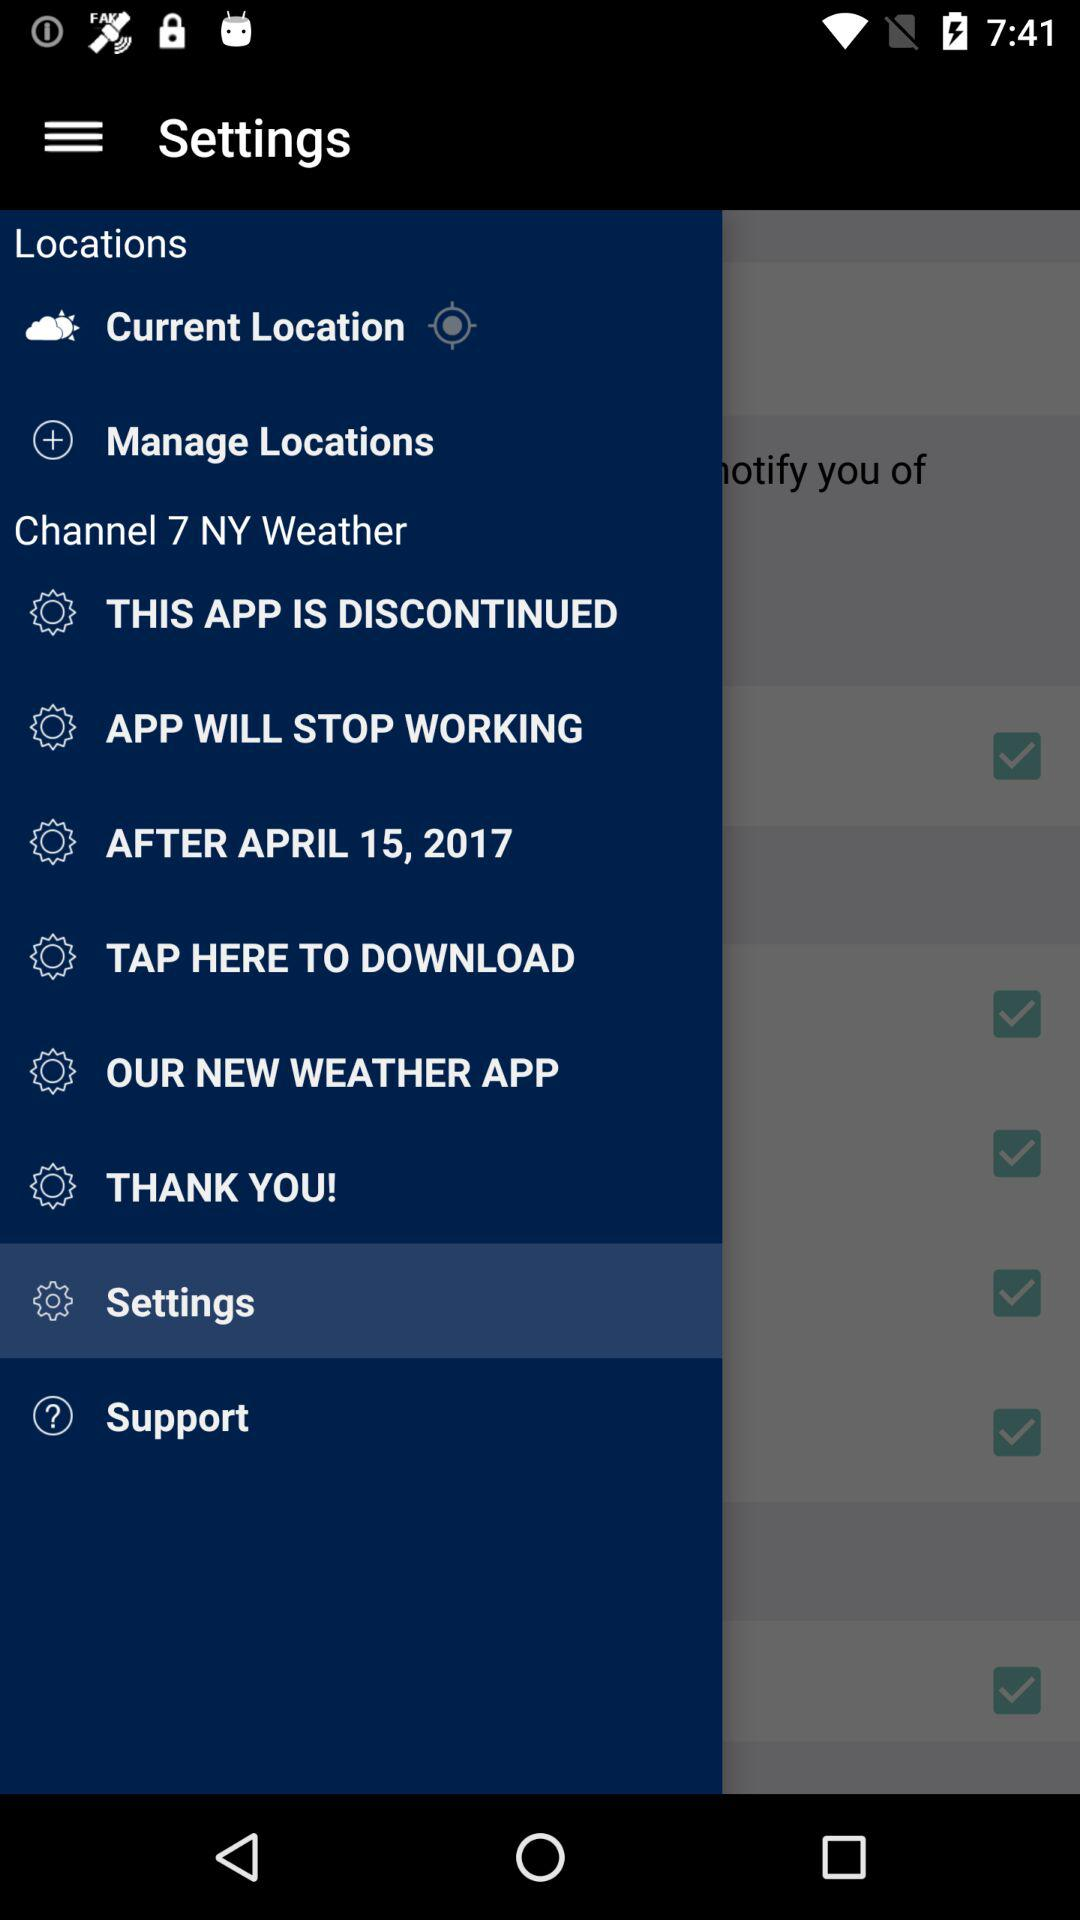Which item is selected in the menu? The item "Settings" is selected in the menu. 